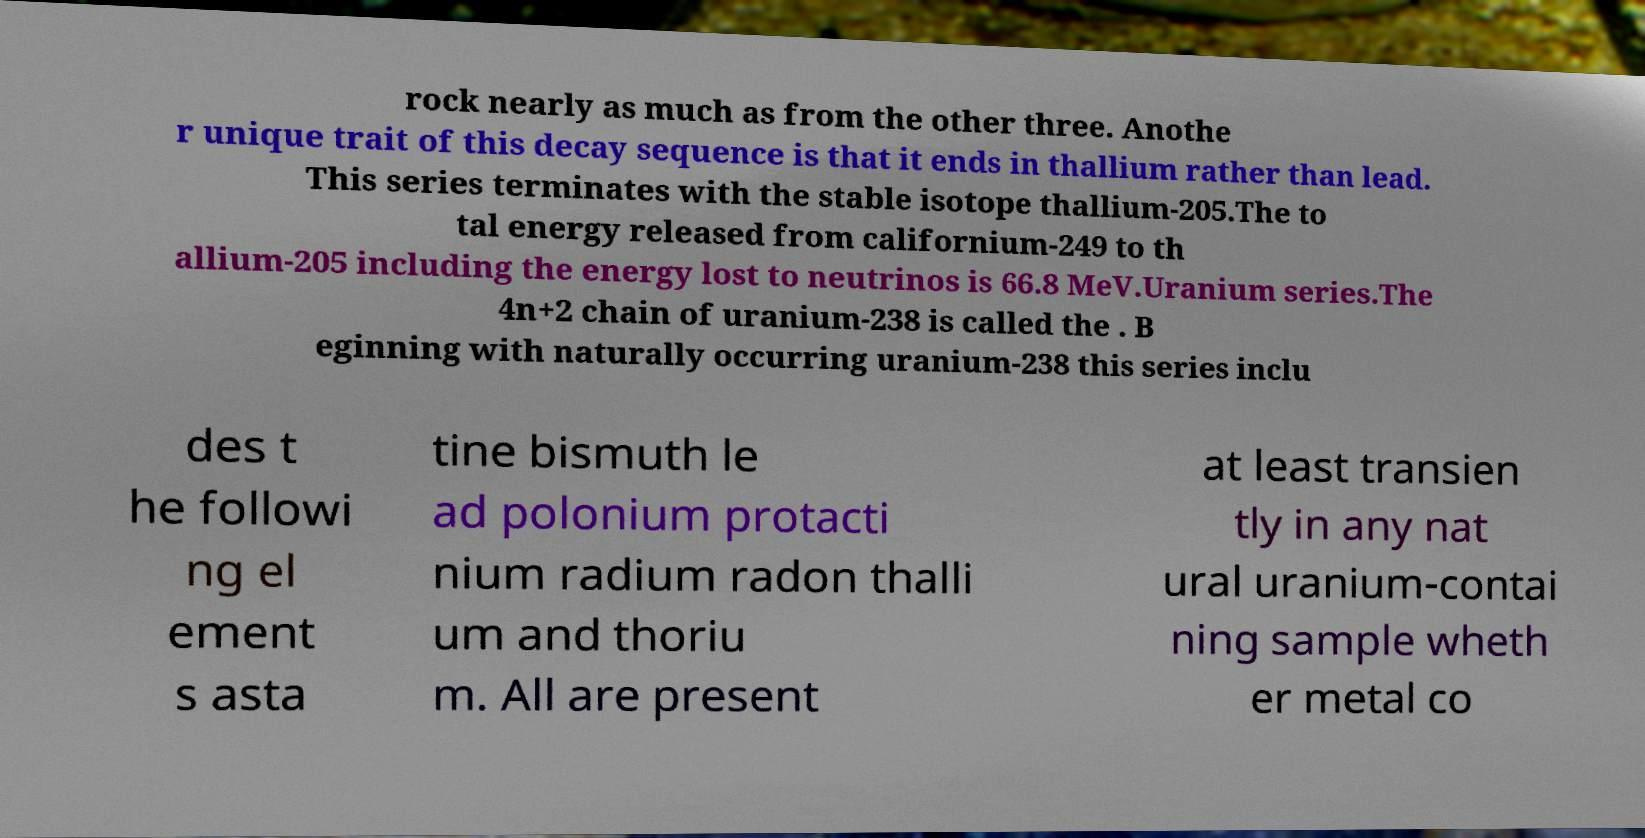Please identify and transcribe the text found in this image. rock nearly as much as from the other three. Anothe r unique trait of this decay sequence is that it ends in thallium rather than lead. This series terminates with the stable isotope thallium-205.The to tal energy released from californium-249 to th allium-205 including the energy lost to neutrinos is 66.8 MeV.Uranium series.The 4n+2 chain of uranium-238 is called the . B eginning with naturally occurring uranium-238 this series inclu des t he followi ng el ement s asta tine bismuth le ad polonium protacti nium radium radon thalli um and thoriu m. All are present at least transien tly in any nat ural uranium-contai ning sample wheth er metal co 